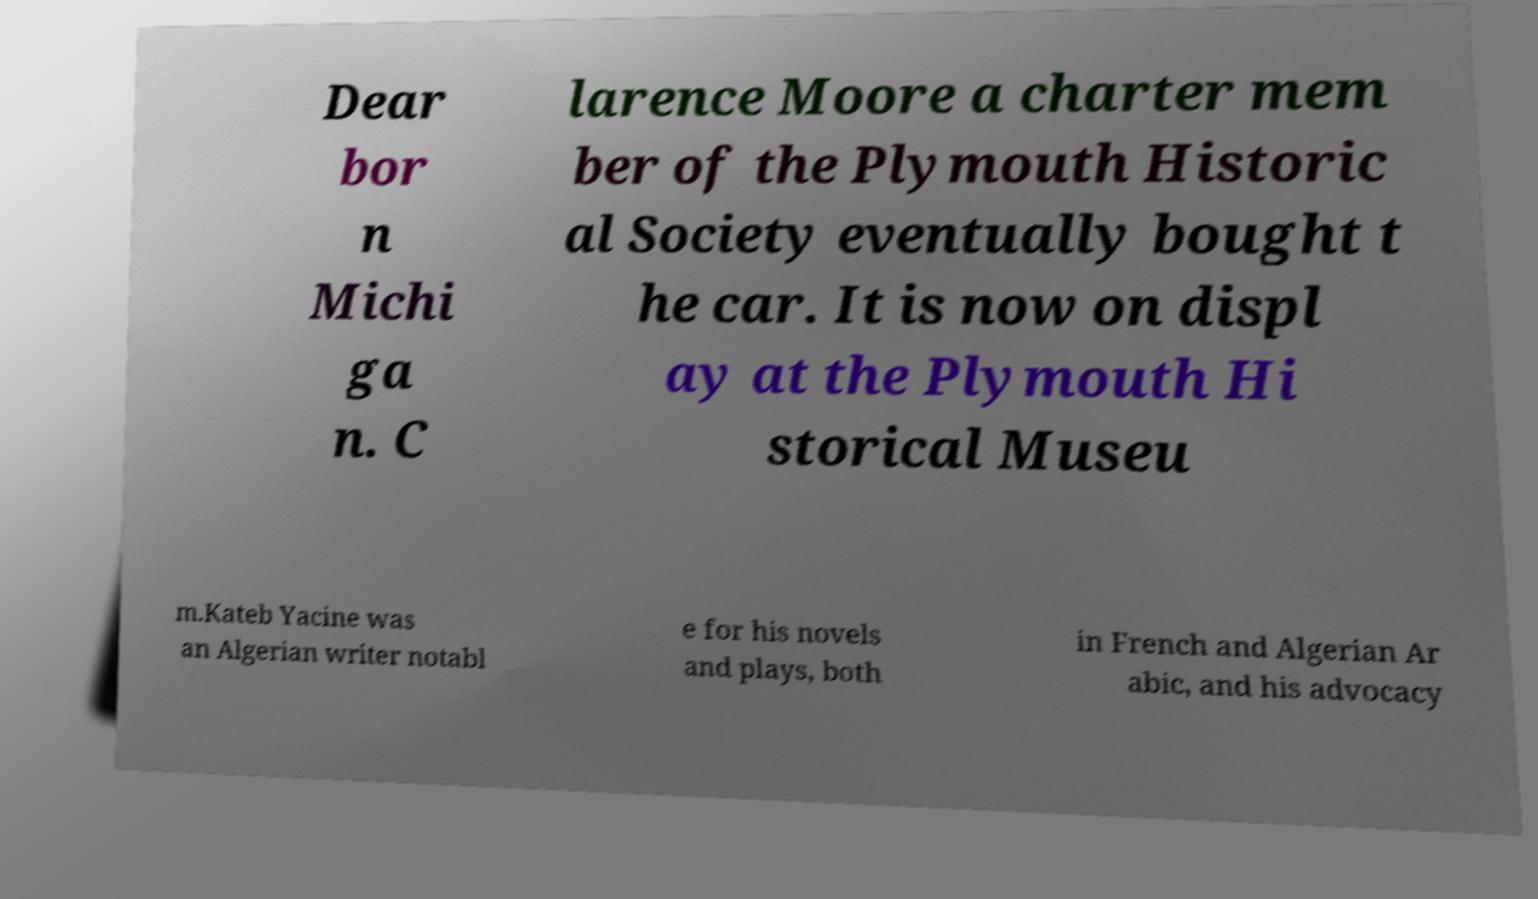Could you assist in decoding the text presented in this image and type it out clearly? Dear bor n Michi ga n. C larence Moore a charter mem ber of the Plymouth Historic al Society eventually bought t he car. It is now on displ ay at the Plymouth Hi storical Museu m.Kateb Yacine was an Algerian writer notabl e for his novels and plays, both in French and Algerian Ar abic, and his advocacy 